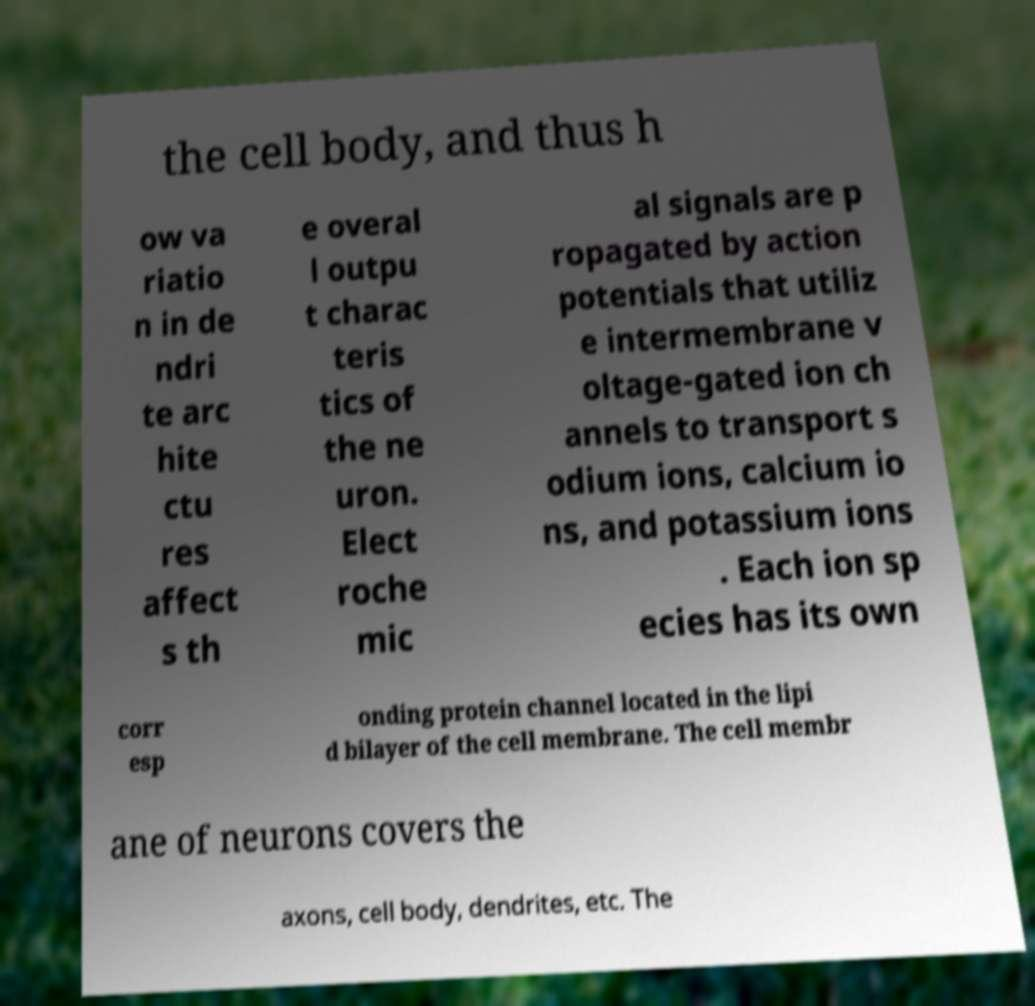Could you assist in decoding the text presented in this image and type it out clearly? the cell body, and thus h ow va riatio n in de ndri te arc hite ctu res affect s th e overal l outpu t charac teris tics of the ne uron. Elect roche mic al signals are p ropagated by action potentials that utiliz e intermembrane v oltage-gated ion ch annels to transport s odium ions, calcium io ns, and potassium ions . Each ion sp ecies has its own corr esp onding protein channel located in the lipi d bilayer of the cell membrane. The cell membr ane of neurons covers the axons, cell body, dendrites, etc. The 